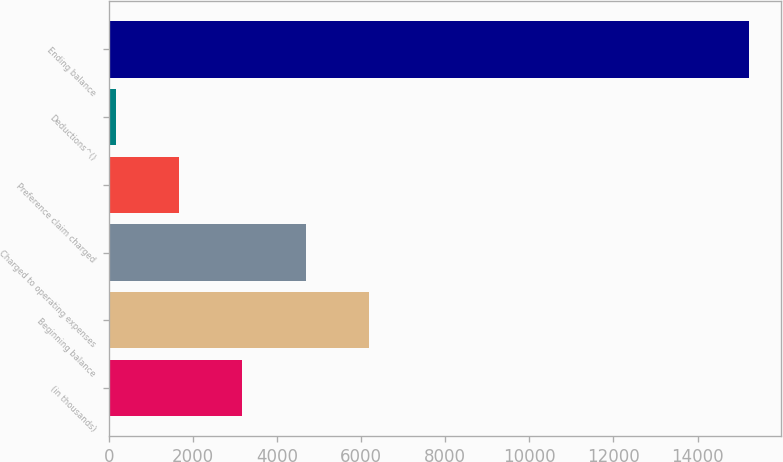Convert chart to OTSL. <chart><loc_0><loc_0><loc_500><loc_500><bar_chart><fcel>(in thousands)<fcel>Beginning balance<fcel>Charged to operating expenses<fcel>Preference claim charged<fcel>Deductions^()<fcel>Ending balance<nl><fcel>3177<fcel>6189<fcel>4683<fcel>1671<fcel>165<fcel>15225<nl></chart> 